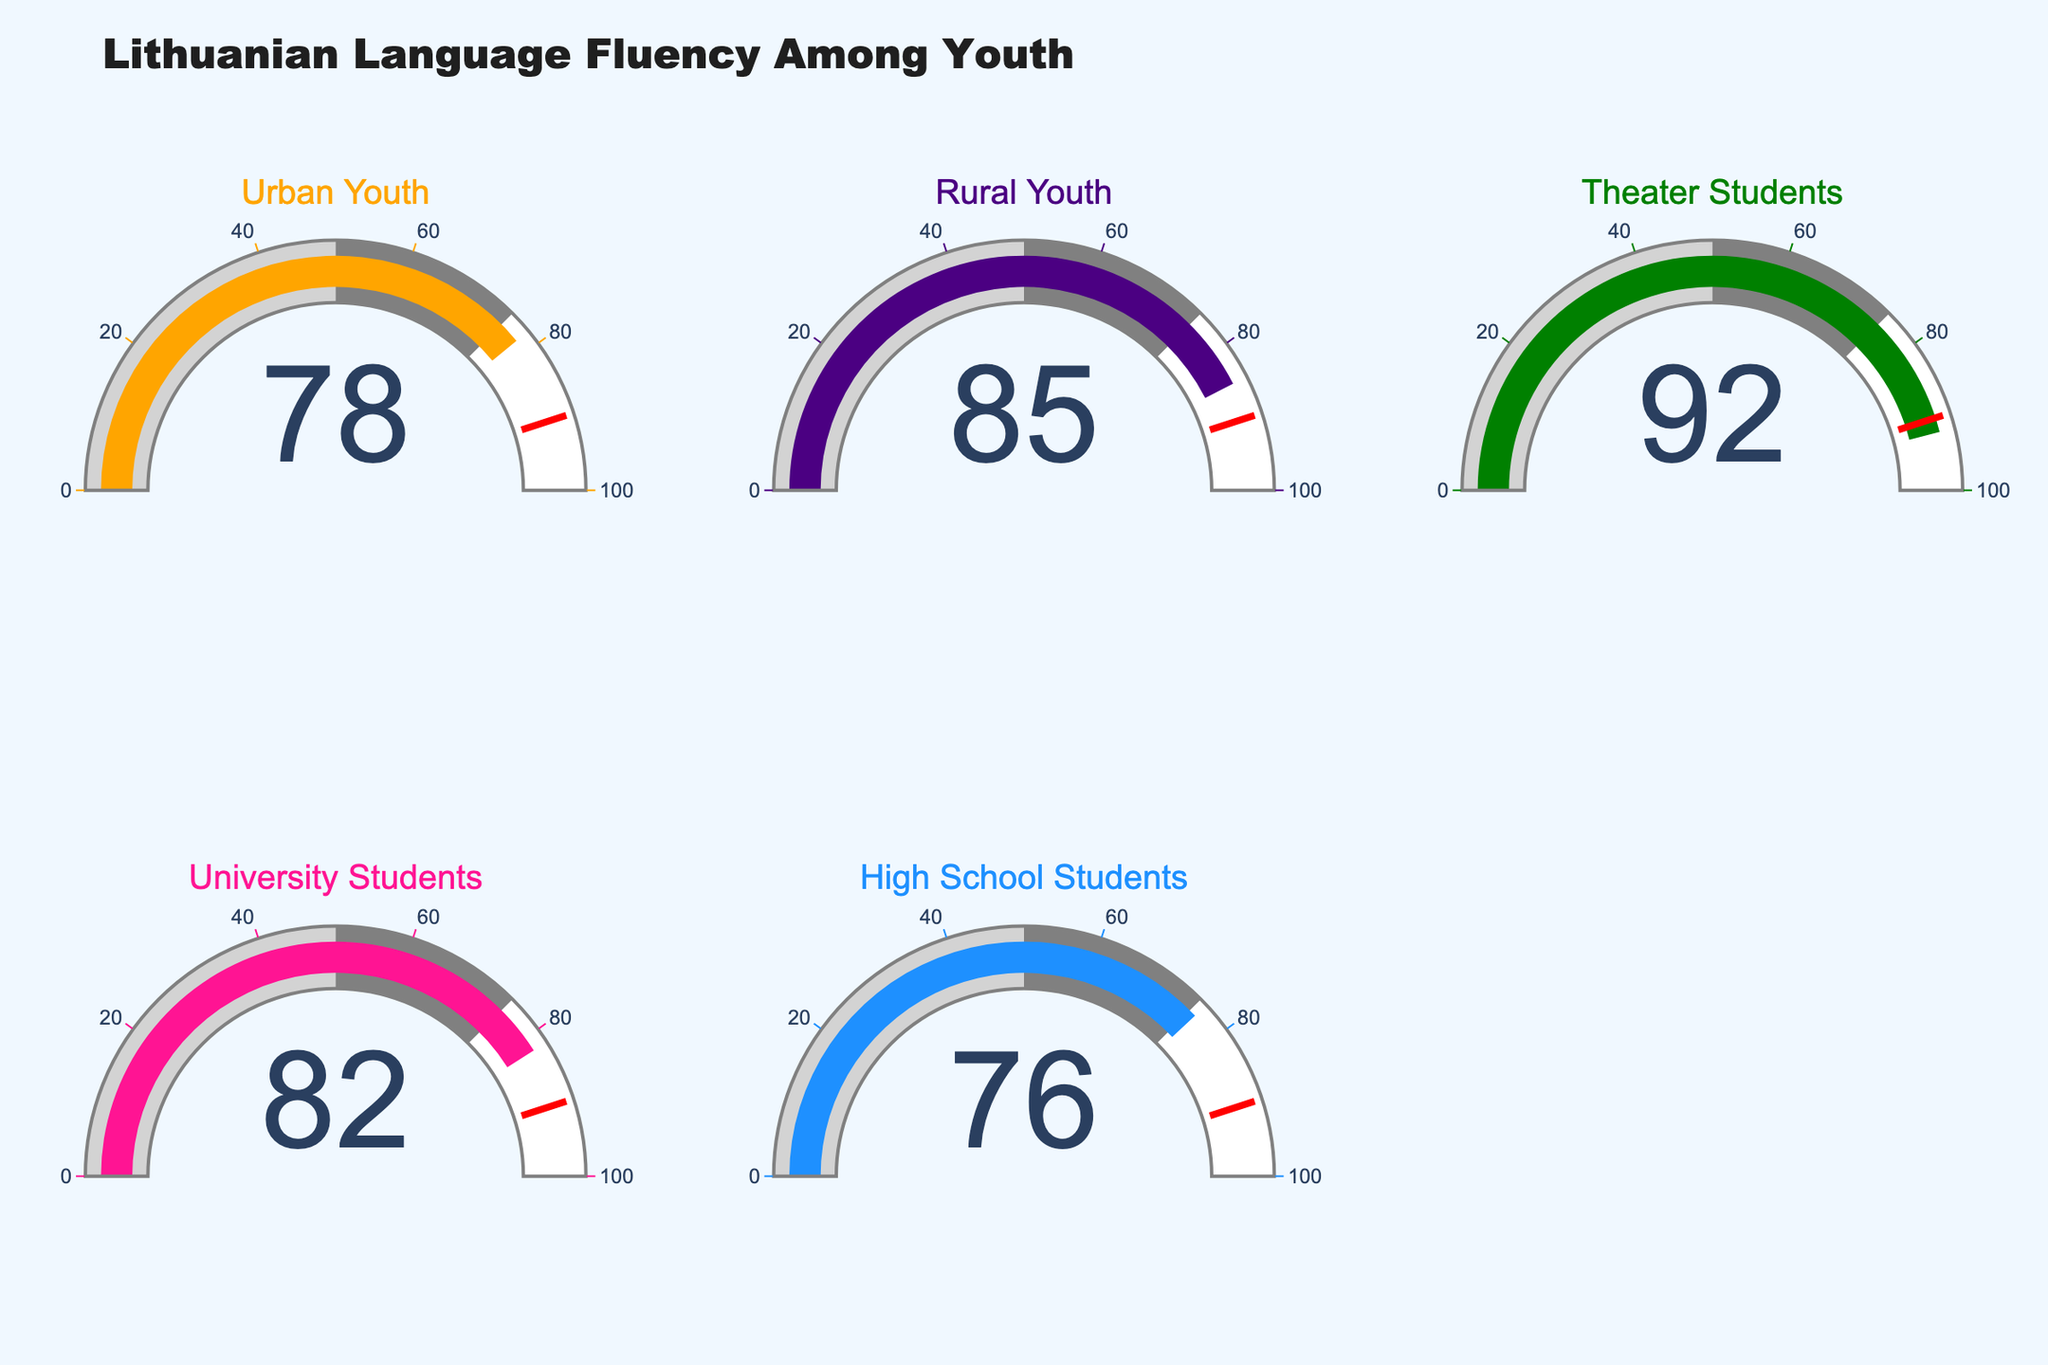What is the title of the figure? The title of the figure is usually stated at the top and summarises the overall data presented. Here, the title "Lithuanian Language Fluency Among Youth" is displayed.
Answer: Lithuanian Language Fluency Among Youth Which group has the highest fluency percentage in Lithuanian? The group with the gauge showing the highest number in terms of percentage represents the highest fluency. In this figure, the "Theater Students" gauge shows 92%, which is the highest among all groups.
Answer: Theater Students What is the fluency percentage for Urban Youth? The percentage for Urban Youth can be seen on its respective gauge, which is marked clearly.
Answer: 78 What are the fluency percentages for both University Students and High School Students combined? Add the two percentages shown on individual gauges for these groups: University Students is 82 and High School Students is 76. Thus, 82 + 76 = 158.
Answer: 158 What is the difference in percentage between Rural Youth and Urban Youth? The percentage for Rural Youth is 85, and Urban Youth is 78. Subtract Urban Youth's percentage from Rural Youth's: 85 - 78 = 7.
Answer: 7 Among High School Students and University Students, which group has a higher fluency percentage and by how much? Compare the percentages on their respective gauges. University Students have 82 and High School Students have 76. Subtract: 82 - 76 = 6. University Students have a 6% higher fluency.
Answer: University Students by 6% Is there any group that has less than 80% fluency? If so, which one? Check each gauge for percentages less than 80%. Only High School Students (76%) and Urban Youth (78%) have percentages below 80%.
Answer: High School Students, Urban Youth What percentage marks the threshold for highlighting in red on the gauge? The red highlight appears at the percentage marked on the outer scale of the gauges. It is defined to mark a threshold above which the performance is noteworthy. In this figure, this threshold is clearly 90%.
Answer: 90 